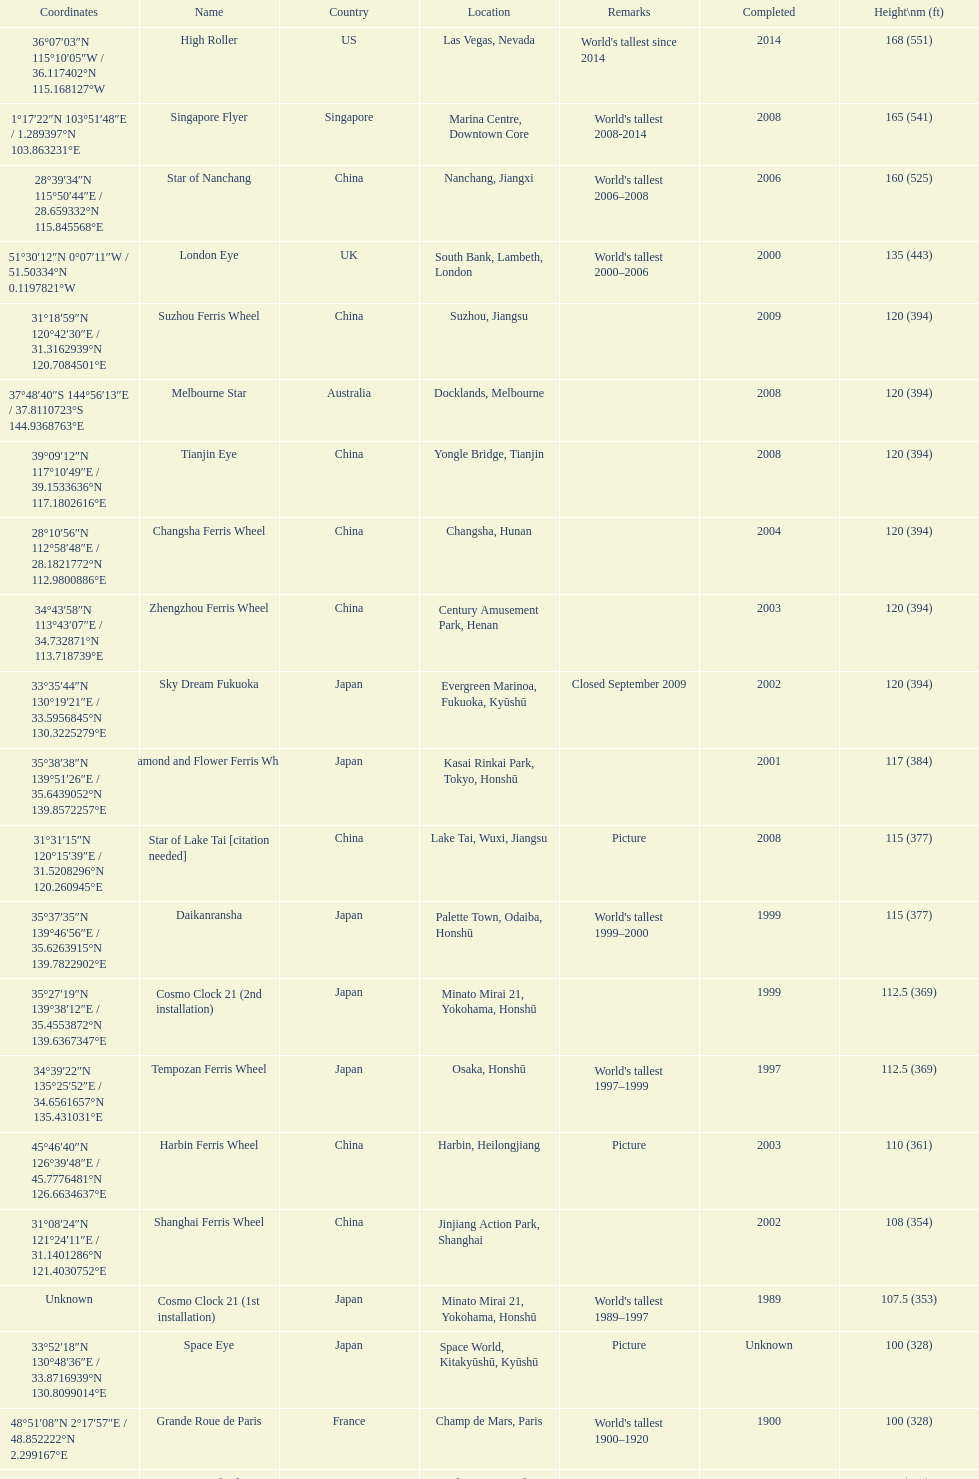Could you parse the entire table as a dict? {'header': ['Coordinates', 'Name', 'Country', 'Location', 'Remarks', 'Completed', 'Height\\nm (ft)'], 'rows': [['36°07′03″N 115°10′05″W\ufeff / \ufeff36.117402°N 115.168127°W', 'High Roller', 'US', 'Las Vegas, Nevada', "World's tallest since 2014", '2014', '168 (551)'], ['1°17′22″N 103°51′48″E\ufeff / \ufeff1.289397°N 103.863231°E', 'Singapore Flyer', 'Singapore', 'Marina Centre, Downtown Core', "World's tallest 2008-2014", '2008', '165 (541)'], ['28°39′34″N 115°50′44″E\ufeff / \ufeff28.659332°N 115.845568°E', 'Star of Nanchang', 'China', 'Nanchang, Jiangxi', "World's tallest 2006–2008", '2006', '160 (525)'], ['51°30′12″N 0°07′11″W\ufeff / \ufeff51.50334°N 0.1197821°W', 'London Eye', 'UK', 'South Bank, Lambeth, London', "World's tallest 2000–2006", '2000', '135 (443)'], ['31°18′59″N 120°42′30″E\ufeff / \ufeff31.3162939°N 120.7084501°E', 'Suzhou Ferris Wheel', 'China', 'Suzhou, Jiangsu', '', '2009', '120 (394)'], ['37°48′40″S 144°56′13″E\ufeff / \ufeff37.8110723°S 144.9368763°E', 'Melbourne Star', 'Australia', 'Docklands, Melbourne', '', '2008', '120 (394)'], ['39°09′12″N 117°10′49″E\ufeff / \ufeff39.1533636°N 117.1802616°E', 'Tianjin Eye', 'China', 'Yongle Bridge, Tianjin', '', '2008', '120 (394)'], ['28°10′56″N 112°58′48″E\ufeff / \ufeff28.1821772°N 112.9800886°E', 'Changsha Ferris Wheel', 'China', 'Changsha, Hunan', '', '2004', '120 (394)'], ['34°43′58″N 113°43′07″E\ufeff / \ufeff34.732871°N 113.718739°E', 'Zhengzhou Ferris Wheel', 'China', 'Century Amusement Park, Henan', '', '2003', '120 (394)'], ['33°35′44″N 130°19′21″E\ufeff / \ufeff33.5956845°N 130.3225279°E', 'Sky Dream Fukuoka', 'Japan', 'Evergreen Marinoa, Fukuoka, Kyūshū', 'Closed September 2009', '2002', '120 (394)'], ['35°38′38″N 139°51′26″E\ufeff / \ufeff35.6439052°N 139.8572257°E', 'Diamond\xa0and\xa0Flower\xa0Ferris\xa0Wheel', 'Japan', 'Kasai Rinkai Park, Tokyo, Honshū', '', '2001', '117 (384)'], ['31°31′15″N 120°15′39″E\ufeff / \ufeff31.5208296°N 120.260945°E', 'Star of Lake Tai\xa0[citation needed]', 'China', 'Lake Tai, Wuxi, Jiangsu', 'Picture', '2008', '115 (377)'], ['35°37′35″N 139°46′56″E\ufeff / \ufeff35.6263915°N 139.7822902°E', 'Daikanransha', 'Japan', 'Palette Town, Odaiba, Honshū', "World's tallest 1999–2000", '1999', '115 (377)'], ['35°27′19″N 139°38′12″E\ufeff / \ufeff35.4553872°N 139.6367347°E', 'Cosmo Clock 21 (2nd installation)', 'Japan', 'Minato Mirai 21, Yokohama, Honshū', '', '1999', '112.5 (369)'], ['34°39′22″N 135°25′52″E\ufeff / \ufeff34.6561657°N 135.431031°E', 'Tempozan Ferris Wheel', 'Japan', 'Osaka, Honshū', "World's tallest 1997–1999", '1997', '112.5 (369)'], ['45°46′40″N 126°39′48″E\ufeff / \ufeff45.7776481°N 126.6634637°E', 'Harbin Ferris Wheel', 'China', 'Harbin, Heilongjiang', 'Picture', '2003', '110 (361)'], ['31°08′24″N 121°24′11″E\ufeff / \ufeff31.1401286°N 121.4030752°E', 'Shanghai Ferris Wheel', 'China', 'Jinjiang Action Park, Shanghai', '', '2002', '108 (354)'], ['Unknown', 'Cosmo Clock 21 (1st installation)', 'Japan', 'Minato Mirai 21, Yokohama, Honshū', "World's tallest 1989–1997", '1989', '107.5 (353)'], ['33°52′18″N 130°48′36″E\ufeff / \ufeff33.8716939°N 130.8099014°E', 'Space Eye', 'Japan', 'Space World, Kitakyūshū, Kyūshū', 'Picture', 'Unknown', '100 (328)'], ['48°51′08″N 2°17′57″E\ufeff / \ufeff48.852222°N 2.299167°E', 'Grande Roue de Paris', 'France', 'Champ de Mars, Paris', "World's tallest 1900–1920", '1900', '100 (328)'], ['51°29′18″N 0°11′56″W\ufeff / \ufeff51.48835°N 0.19889°W', 'Great Wheel', 'UK', 'Earls Court, London', "World's tallest 1895–1900", '1895', '94 (308)'], ['35°01′47″N 136°44′01″E\ufeff / \ufeff35.0298207°N 136.7336351°E', 'Aurora Wheel', 'Japan', 'Nagashima Spa Land, Mie, Honshū', 'Picture', 'Unknown', '90 (295)'], ['44°20′21″N 12°15′44″E\ufeff / \ufeff44.3392161°N 12.2622228°E', 'Eurowheel', 'Italy', 'Mirabilandia, Ravenna', '', '1999', '90 (295)'], ['23°37′13″N 120°34′35″E\ufeff / \ufeff23.6202611°N 120.5763352°E', 'Sky Wheel', 'Taiwan', 'Janfusun Fancyworld, Gukeng', '', 'Unknown', '88 (289)'], ['34°48′14″N 135°32′09″E\ufeff / \ufeff34.803772°N 135.535916°E\\n36°03′40″N 140°04′23″E\ufeff / \ufeff36.061203°N 140.073055°E', 'Technostar\\nTechnocosmos', 'Japan', "Expoland, Osaka, Honshū (?-2009)\\nExpo '85, Tsukuba, Honshū (1985-?)", "Technocosmos renamed/relocated\\nWorld's tallest extant 1985–1989", '?\\n1985', '85 (279)'], ['Ferris Wheel coordinates', 'The original Ferris Wheel', 'US', 'Chicago (1893–1903); St. Louis (1904–06)', "World's tallest 1893–1894", '1893', '80.4 (264)']]} Where was the original tallest roller coster built? Chicago. 